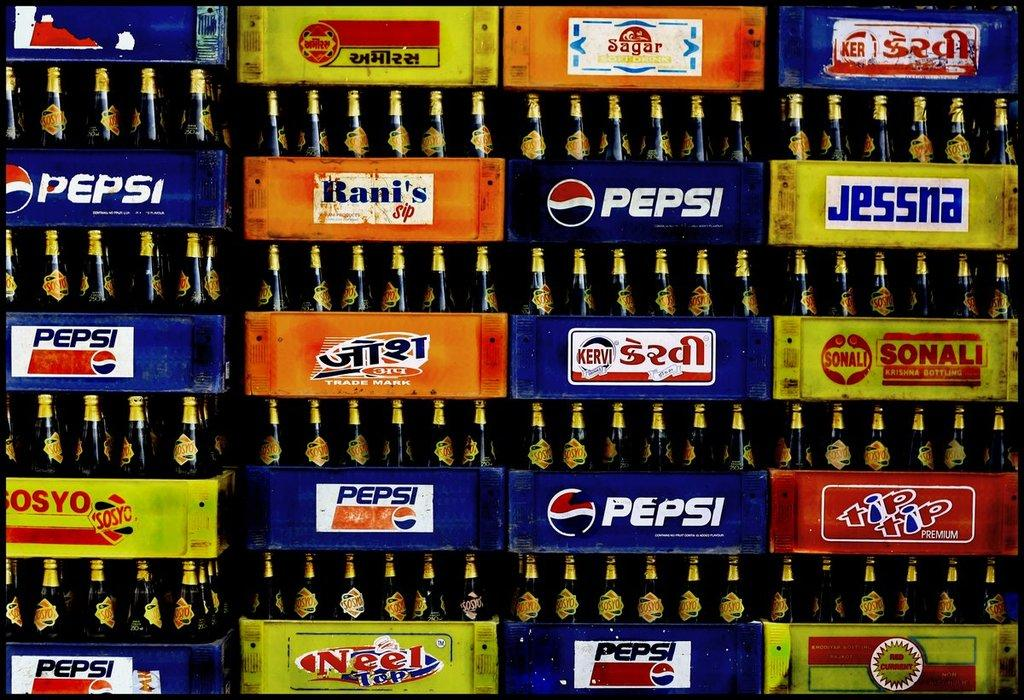Provide a one-sentence caption for the provided image. A stack of bottles in crates that say Pepsi. 